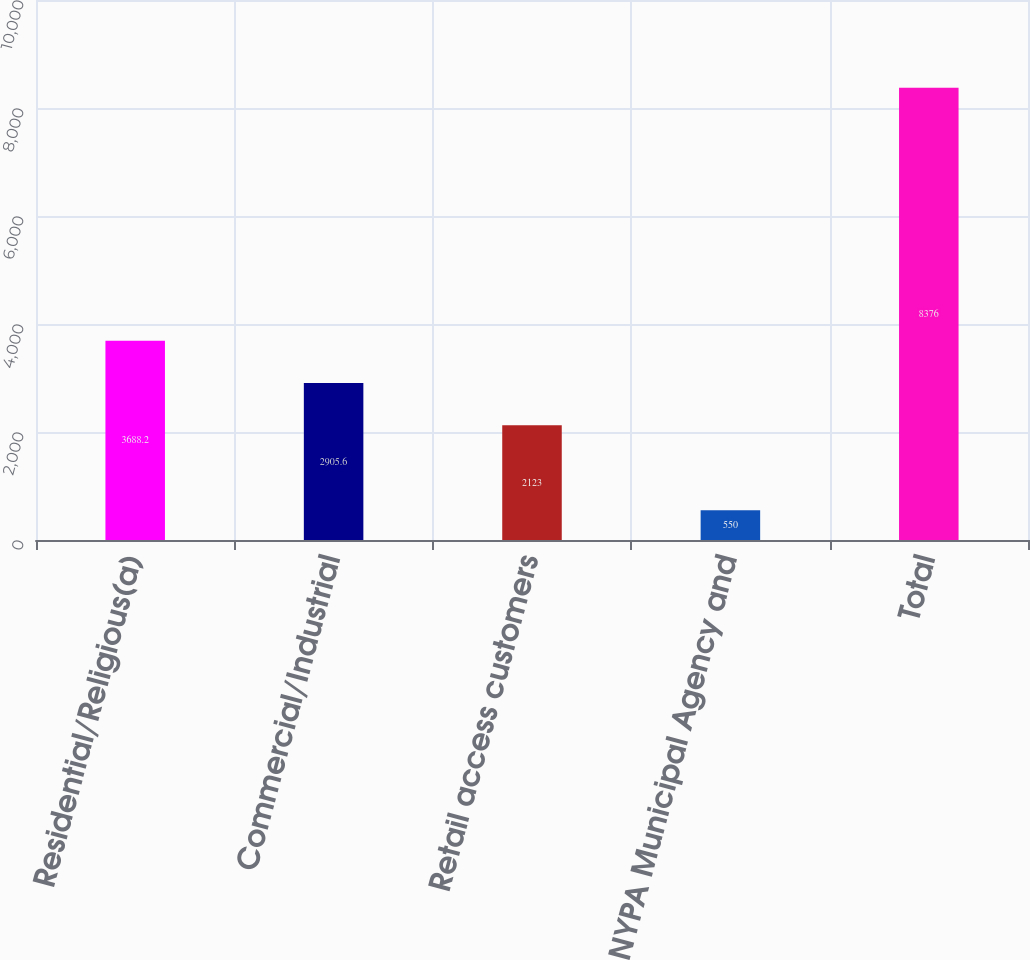<chart> <loc_0><loc_0><loc_500><loc_500><bar_chart><fcel>Residential/Religious(a)<fcel>Commercial/Industrial<fcel>Retail access customers<fcel>NYPA Municipal Agency and<fcel>Total<nl><fcel>3688.2<fcel>2905.6<fcel>2123<fcel>550<fcel>8376<nl></chart> 